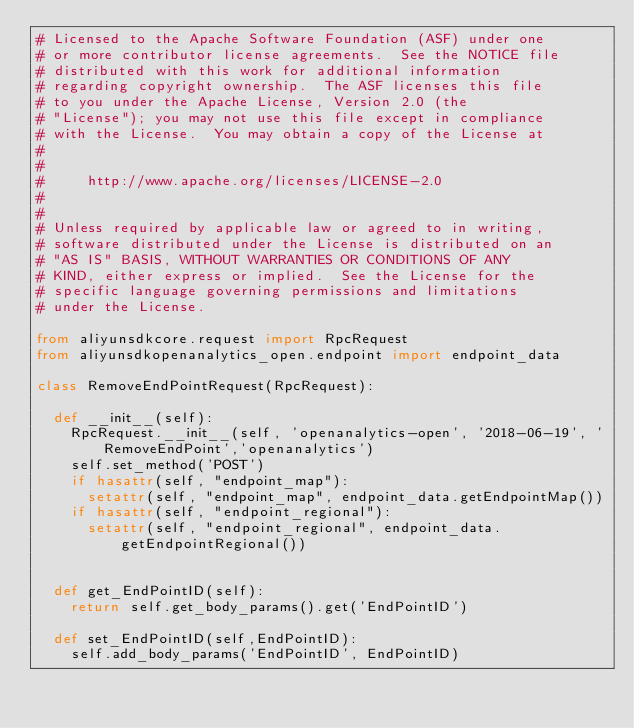Convert code to text. <code><loc_0><loc_0><loc_500><loc_500><_Python_># Licensed to the Apache Software Foundation (ASF) under one
# or more contributor license agreements.  See the NOTICE file
# distributed with this work for additional information
# regarding copyright ownership.  The ASF licenses this file
# to you under the Apache License, Version 2.0 (the
# "License"); you may not use this file except in compliance
# with the License.  You may obtain a copy of the License at
#
#
#     http://www.apache.org/licenses/LICENSE-2.0
#
#
# Unless required by applicable law or agreed to in writing,
# software distributed under the License is distributed on an
# "AS IS" BASIS, WITHOUT WARRANTIES OR CONDITIONS OF ANY
# KIND, either express or implied.  See the License for the
# specific language governing permissions and limitations
# under the License.

from aliyunsdkcore.request import RpcRequest
from aliyunsdkopenanalytics_open.endpoint import endpoint_data

class RemoveEndPointRequest(RpcRequest):

	def __init__(self):
		RpcRequest.__init__(self, 'openanalytics-open', '2018-06-19', 'RemoveEndPoint','openanalytics')
		self.set_method('POST')
		if hasattr(self, "endpoint_map"):
			setattr(self, "endpoint_map", endpoint_data.getEndpointMap())
		if hasattr(self, "endpoint_regional"):
			setattr(self, "endpoint_regional", endpoint_data.getEndpointRegional())


	def get_EndPointID(self):
		return self.get_body_params().get('EndPointID')

	def set_EndPointID(self,EndPointID):
		self.add_body_params('EndPointID', EndPointID)</code> 